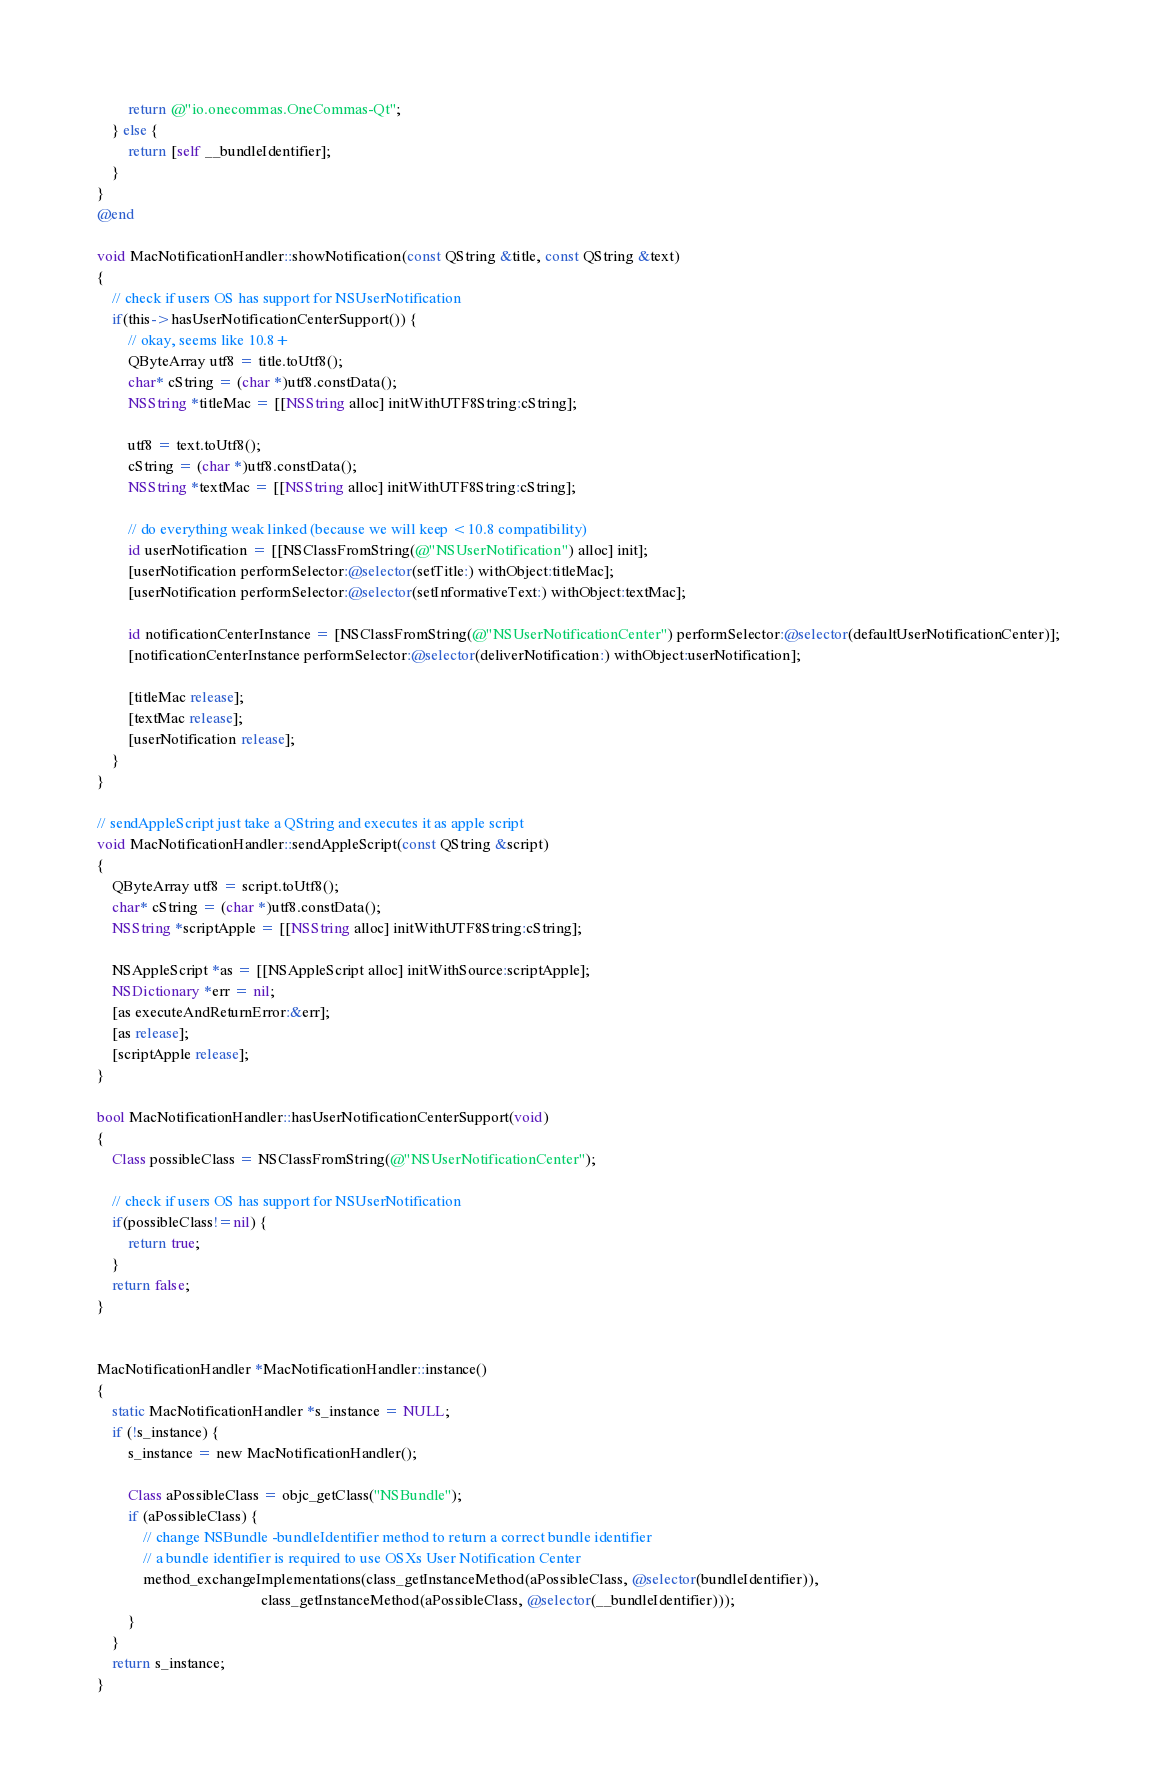<code> <loc_0><loc_0><loc_500><loc_500><_ObjectiveC_>        return @"io.onecommas.OneCommas-Qt";
    } else {
        return [self __bundleIdentifier];
    }
}
@end

void MacNotificationHandler::showNotification(const QString &title, const QString &text)
{
    // check if users OS has support for NSUserNotification
    if(this->hasUserNotificationCenterSupport()) {
        // okay, seems like 10.8+
        QByteArray utf8 = title.toUtf8();
        char* cString = (char *)utf8.constData();
        NSString *titleMac = [[NSString alloc] initWithUTF8String:cString];

        utf8 = text.toUtf8();
        cString = (char *)utf8.constData();
        NSString *textMac = [[NSString alloc] initWithUTF8String:cString];

        // do everything weak linked (because we will keep <10.8 compatibility)
        id userNotification = [[NSClassFromString(@"NSUserNotification") alloc] init];
        [userNotification performSelector:@selector(setTitle:) withObject:titleMac];
        [userNotification performSelector:@selector(setInformativeText:) withObject:textMac];

        id notificationCenterInstance = [NSClassFromString(@"NSUserNotificationCenter") performSelector:@selector(defaultUserNotificationCenter)];
        [notificationCenterInstance performSelector:@selector(deliverNotification:) withObject:userNotification];

        [titleMac release];
        [textMac release];
        [userNotification release];
    }
}

// sendAppleScript just take a QString and executes it as apple script
void MacNotificationHandler::sendAppleScript(const QString &script)
{
    QByteArray utf8 = script.toUtf8();
    char* cString = (char *)utf8.constData();
    NSString *scriptApple = [[NSString alloc] initWithUTF8String:cString];

    NSAppleScript *as = [[NSAppleScript alloc] initWithSource:scriptApple];
    NSDictionary *err = nil;
    [as executeAndReturnError:&err];
    [as release];
    [scriptApple release];
}

bool MacNotificationHandler::hasUserNotificationCenterSupport(void)
{
    Class possibleClass = NSClassFromString(@"NSUserNotificationCenter");

    // check if users OS has support for NSUserNotification
    if(possibleClass!=nil) {
        return true;
    }
    return false;
}


MacNotificationHandler *MacNotificationHandler::instance()
{
    static MacNotificationHandler *s_instance = NULL;
    if (!s_instance) {
        s_instance = new MacNotificationHandler();
        
        Class aPossibleClass = objc_getClass("NSBundle");
        if (aPossibleClass) {
            // change NSBundle -bundleIdentifier method to return a correct bundle identifier
            // a bundle identifier is required to use OSXs User Notification Center
            method_exchangeImplementations(class_getInstanceMethod(aPossibleClass, @selector(bundleIdentifier)),
                                           class_getInstanceMethod(aPossibleClass, @selector(__bundleIdentifier)));
        }
    }
    return s_instance;
}
</code> 